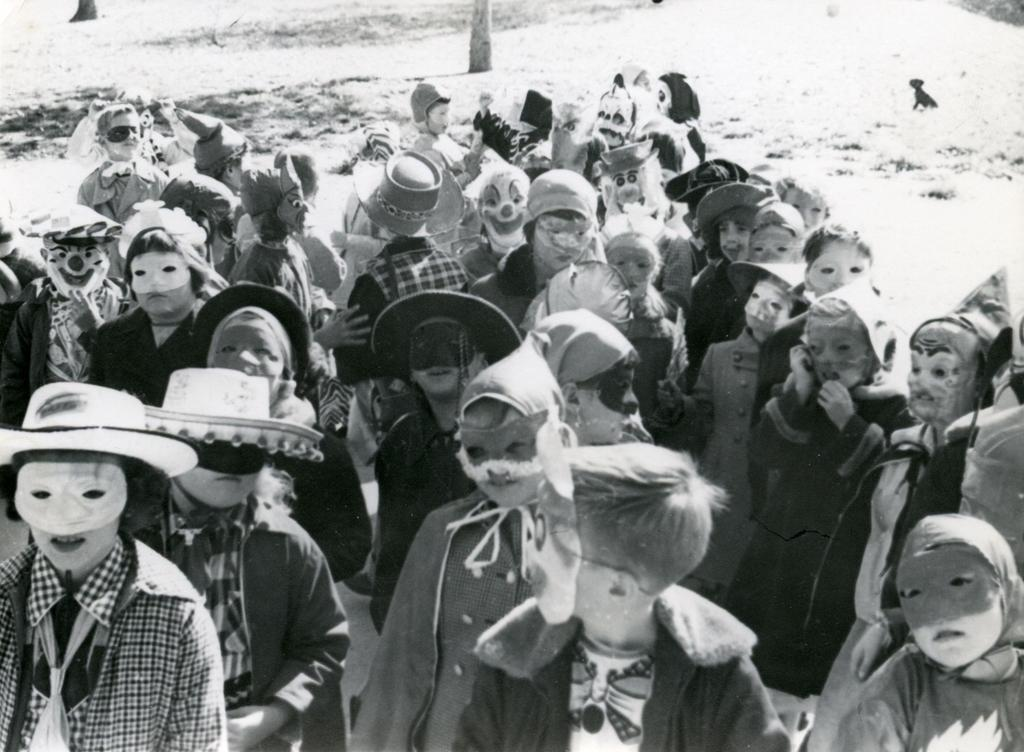What is the color scheme of the image? The image is black and white. What are the people in the image wearing? The people in the image are wearing masks. What can be seen in the background of the image? Tree barks are visible in the background of the image. What type of floor can be seen in the image? There is no floor visible in the image, as it is a black and white image with people wearing masks and tree barks in the background. 